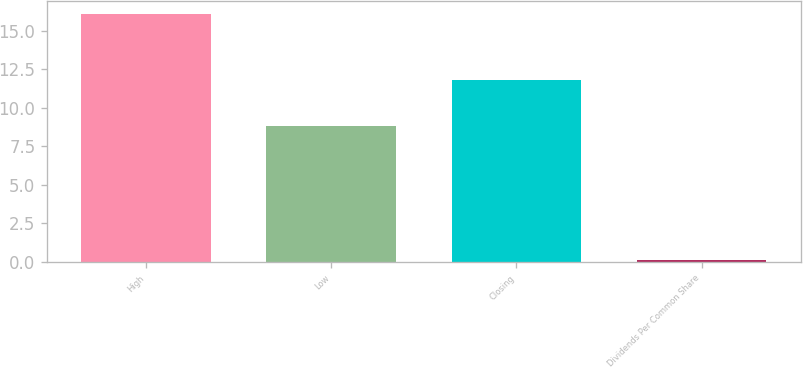<chart> <loc_0><loc_0><loc_500><loc_500><bar_chart><fcel>High<fcel>Low<fcel>Closing<fcel>Dividends Per Common Share<nl><fcel>16.11<fcel>8.8<fcel>11.77<fcel>0.14<nl></chart> 